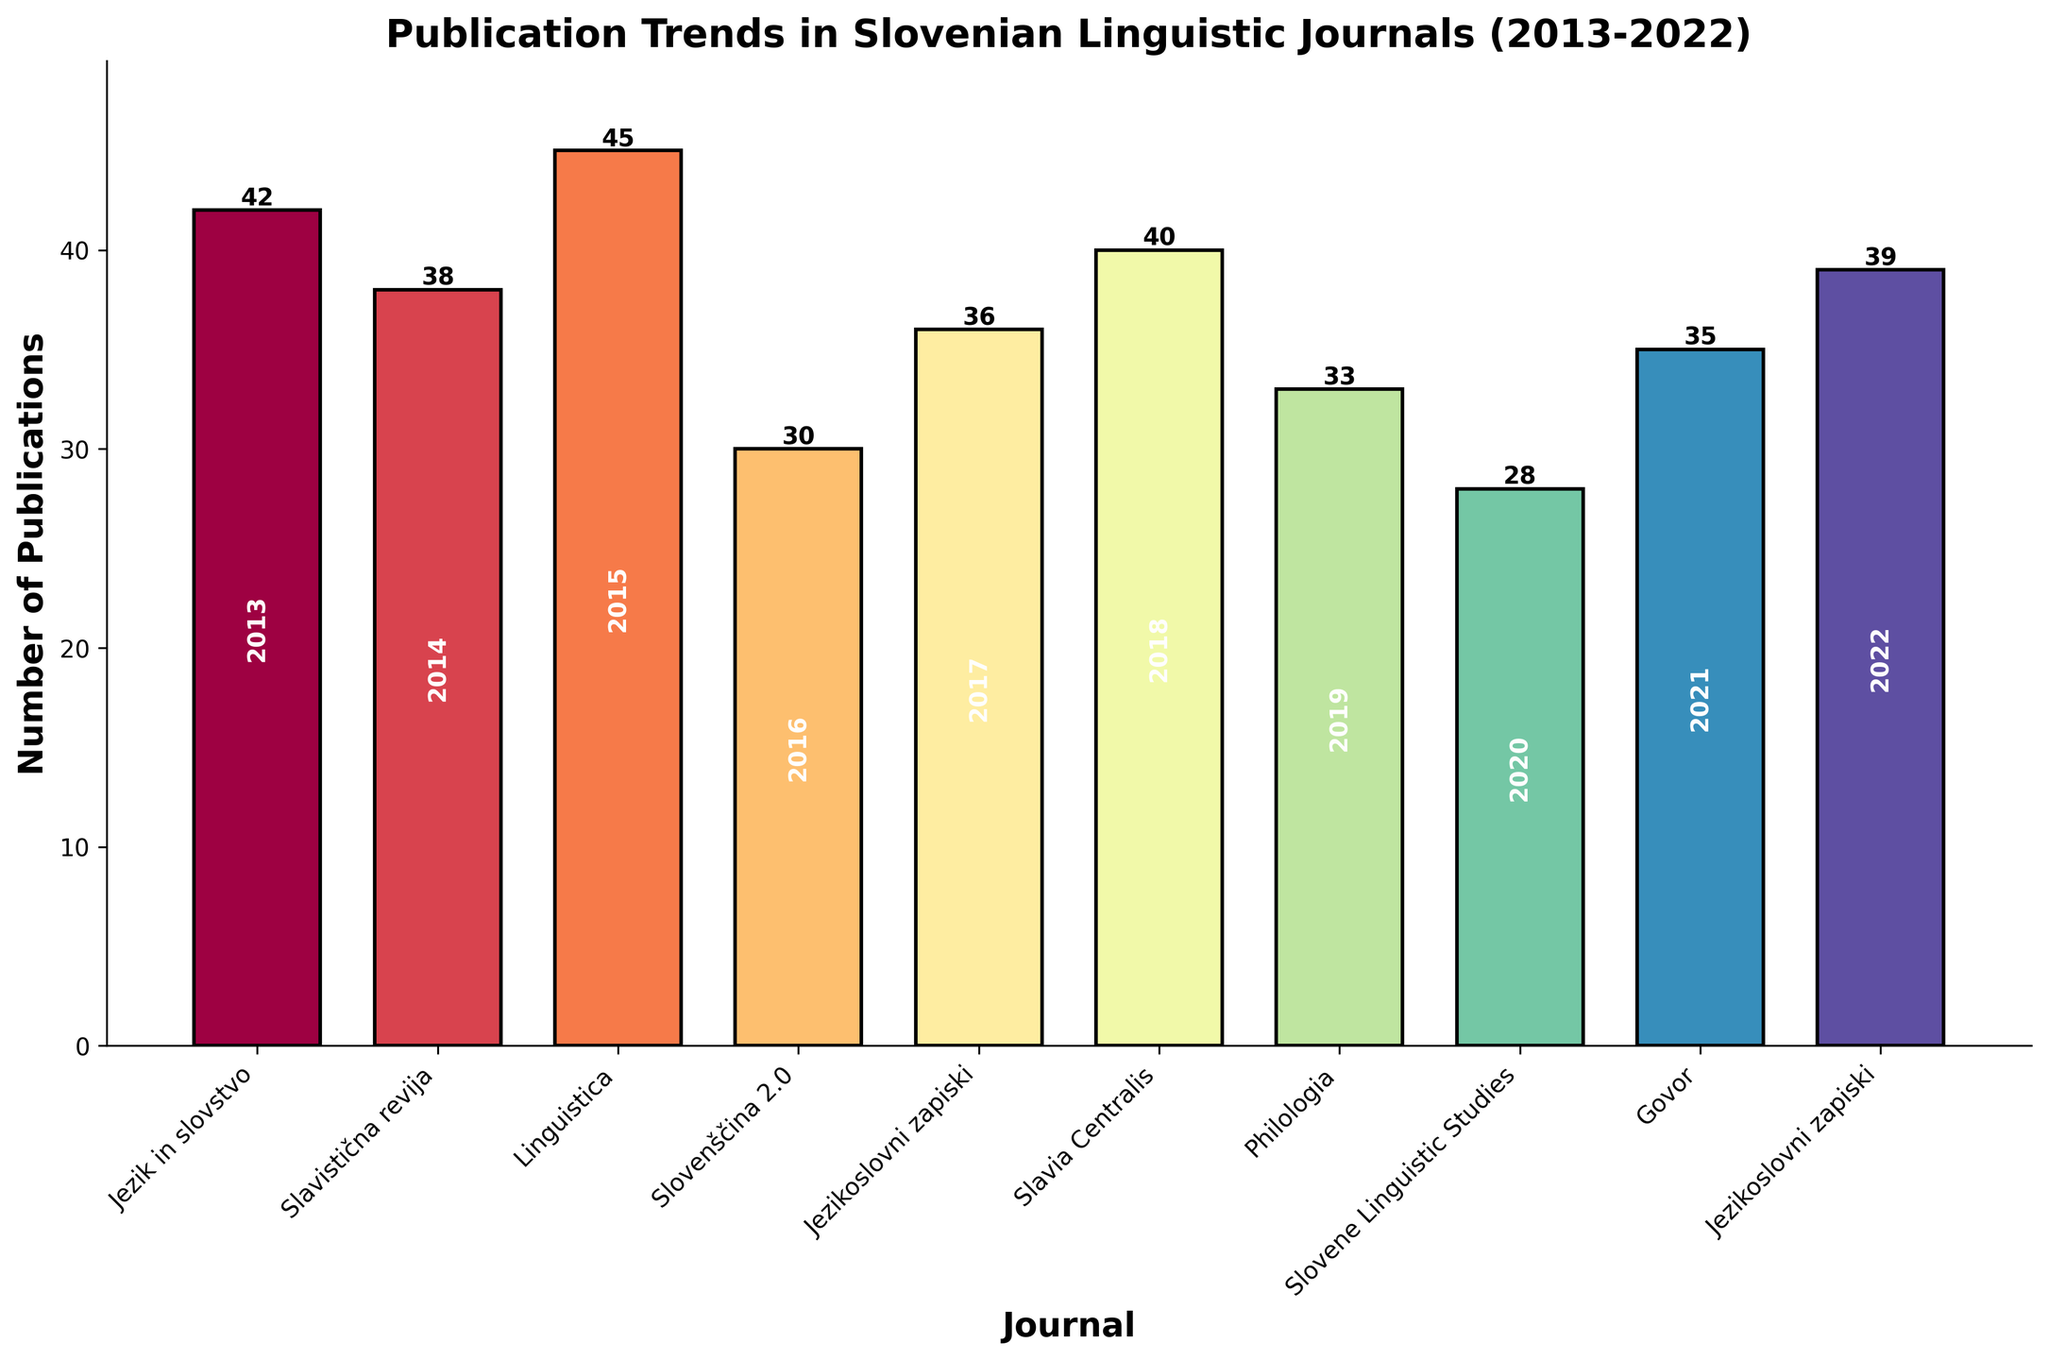What's the overall trend in the number of publications over the years? To find the overall trend, we observe the heights of the bars from left to right. The bars don't appear to follow a consistent pattern of increase or decrease, indicating no clear overall trend.
Answer: No clear trend Which journal had the highest number of publications? By comparing the heights of all the bars, the tallest bar corresponds to "Linguistica" with 45 publications in 2015.
Answer: Linguistica Which year had the fewest publications and in which journal? The shortest bar indicates the fewest publications, corresponding to "Slovene Linguistic Studies" with 28 publications in 2020.
Answer: 2020, Slovene Linguistic Studies How does the number of publications in "Jezikoslovni zapiski" change from 2017 to 2022? Compare the heights of the two bars for "Jezikoslovni zapiski" in the years 2017 and 2022. In 2017, there are 36 publications, and in 2022, there are 39 publications. Thus, it increased by 3 publications.
Answer: Increased by 3 Which journal(s) had more than 40 publications and what are the exact numbers? Identify bars taller than 40 publications. "Jezik in slovstvo" in 2013 had 42 publications, "Linguistica" in 2015 had 45, and "Slavia Centralis" in 2018 had 40.
Answer: Jezik in slovstvo (42), Linguistica (45), Slavia Centralis (40) What is the average number of publications per year for "Jezikoslovni zapiski"? Calculate the sum of publications (36 in 2017 and 39 in 2022) and divide by the number of years (2). (36 + 39) / 2 = 75 / 2 = 37.5
Answer: 37.5 Between which consecutive years did "Philologia" experience the largest decrease in the number of publications? Check the height difference between consecutive years for "Philologia". Since there is data only for 2019 with 33 publications, there's no year-to-year comparison possible for this journal.
Answer: Not applicable What is the difference in the number of publications between "Slavistična revija" in 2014 and "Govor" in 2021? Find the heights of the bars for "Slavistična revija" (38 publications) and "Govor" (35 publications). The difference is 38 - 35 = 3 publications.
Answer: 3 What is the total number of publications in 2018 across all journals? Consider only bars for 2018 and sum their heights. "Slavia Centralis" had 40 publications in 2018.
Answer: 40 